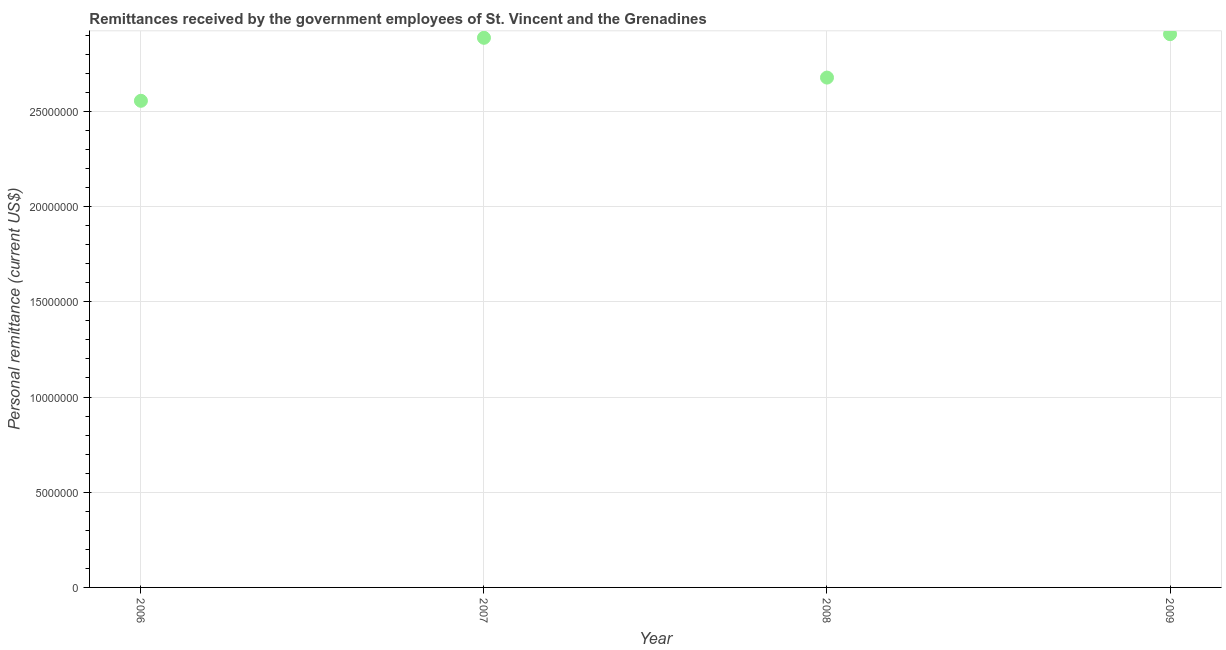What is the personal remittances in 2008?
Ensure brevity in your answer.  2.68e+07. Across all years, what is the maximum personal remittances?
Your response must be concise. 2.91e+07. Across all years, what is the minimum personal remittances?
Your answer should be very brief. 2.56e+07. What is the sum of the personal remittances?
Ensure brevity in your answer.  1.10e+08. What is the difference between the personal remittances in 2007 and 2009?
Make the answer very short. -1.92e+05. What is the average personal remittances per year?
Keep it short and to the point. 2.76e+07. What is the median personal remittances?
Provide a succinct answer. 2.78e+07. In how many years, is the personal remittances greater than 4000000 US$?
Ensure brevity in your answer.  4. Do a majority of the years between 2009 and 2007 (inclusive) have personal remittances greater than 26000000 US$?
Provide a succinct answer. No. What is the ratio of the personal remittances in 2007 to that in 2008?
Provide a short and direct response. 1.08. Is the personal remittances in 2007 less than that in 2009?
Provide a succinct answer. Yes. Is the difference between the personal remittances in 2006 and 2008 greater than the difference between any two years?
Give a very brief answer. No. What is the difference between the highest and the second highest personal remittances?
Offer a terse response. 1.92e+05. Is the sum of the personal remittances in 2007 and 2009 greater than the maximum personal remittances across all years?
Offer a terse response. Yes. What is the difference between the highest and the lowest personal remittances?
Your answer should be very brief. 3.50e+06. How many dotlines are there?
Ensure brevity in your answer.  1. How many years are there in the graph?
Give a very brief answer. 4. What is the difference between two consecutive major ticks on the Y-axis?
Offer a very short reply. 5.00e+06. Does the graph contain grids?
Ensure brevity in your answer.  Yes. What is the title of the graph?
Your response must be concise. Remittances received by the government employees of St. Vincent and the Grenadines. What is the label or title of the X-axis?
Offer a terse response. Year. What is the label or title of the Y-axis?
Provide a succinct answer. Personal remittance (current US$). What is the Personal remittance (current US$) in 2006?
Offer a terse response. 2.56e+07. What is the Personal remittance (current US$) in 2007?
Provide a short and direct response. 2.89e+07. What is the Personal remittance (current US$) in 2008?
Give a very brief answer. 2.68e+07. What is the Personal remittance (current US$) in 2009?
Make the answer very short. 2.91e+07. What is the difference between the Personal remittance (current US$) in 2006 and 2007?
Make the answer very short. -3.31e+06. What is the difference between the Personal remittance (current US$) in 2006 and 2008?
Your answer should be compact. -1.22e+06. What is the difference between the Personal remittance (current US$) in 2006 and 2009?
Your answer should be compact. -3.50e+06. What is the difference between the Personal remittance (current US$) in 2007 and 2008?
Offer a terse response. 2.09e+06. What is the difference between the Personal remittance (current US$) in 2007 and 2009?
Offer a terse response. -1.92e+05. What is the difference between the Personal remittance (current US$) in 2008 and 2009?
Your answer should be very brief. -2.28e+06. What is the ratio of the Personal remittance (current US$) in 2006 to that in 2007?
Keep it short and to the point. 0.89. What is the ratio of the Personal remittance (current US$) in 2006 to that in 2008?
Your answer should be very brief. 0.95. What is the ratio of the Personal remittance (current US$) in 2007 to that in 2008?
Your answer should be very brief. 1.08. What is the ratio of the Personal remittance (current US$) in 2008 to that in 2009?
Provide a succinct answer. 0.92. 